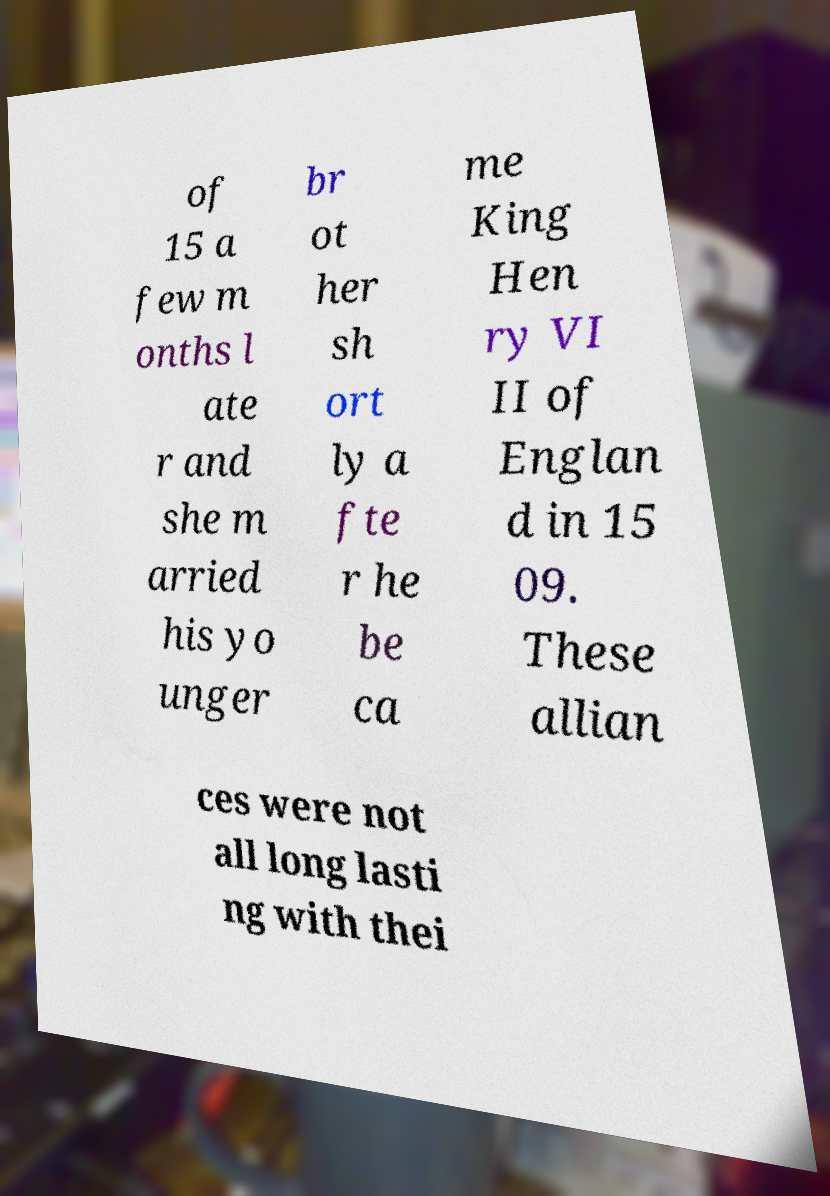Please identify and transcribe the text found in this image. of 15 a few m onths l ate r and she m arried his yo unger br ot her sh ort ly a fte r he be ca me King Hen ry VI II of Englan d in 15 09. These allian ces were not all long lasti ng with thei 